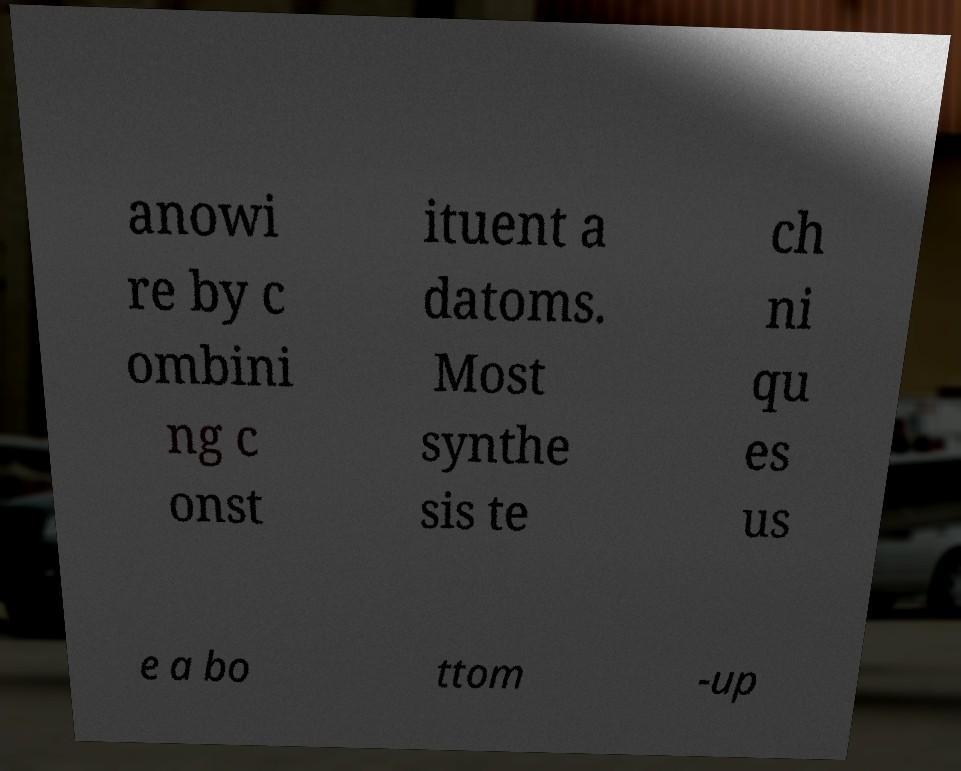What messages or text are displayed in this image? I need them in a readable, typed format. anowi re by c ombini ng c onst ituent a datoms. Most synthe sis te ch ni qu es us e a bo ttom -up 